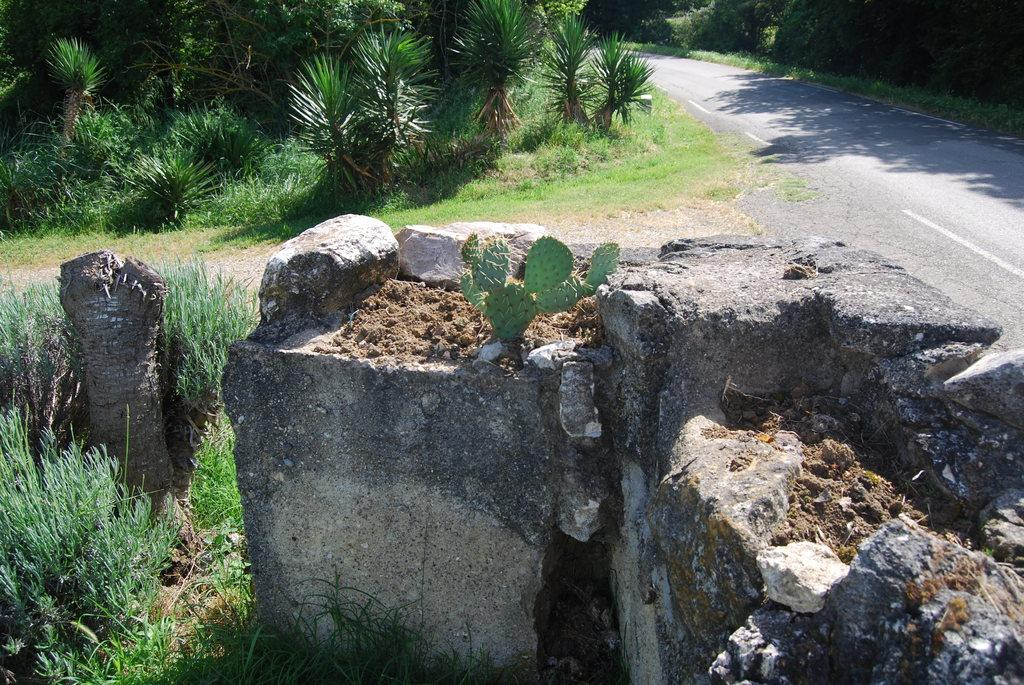What is the main feature of the image? There is a road in the image. What can be seen beside the road? Stones and grass are visible beside the road. Are there any other natural elements in the image? Yes, trees are visible in the image. What type of shirt is hanging from the tree in the image? There is no shirt hanging from the tree in the image; only stones, grass, and trees are present. 